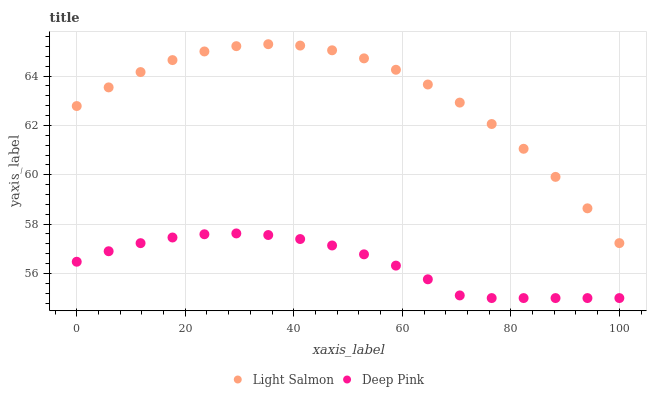Does Deep Pink have the minimum area under the curve?
Answer yes or no. Yes. Does Light Salmon have the maximum area under the curve?
Answer yes or no. Yes. Does Deep Pink have the maximum area under the curve?
Answer yes or no. No. Is Deep Pink the smoothest?
Answer yes or no. Yes. Is Light Salmon the roughest?
Answer yes or no. Yes. Is Deep Pink the roughest?
Answer yes or no. No. Does Deep Pink have the lowest value?
Answer yes or no. Yes. Does Light Salmon have the highest value?
Answer yes or no. Yes. Does Deep Pink have the highest value?
Answer yes or no. No. Is Deep Pink less than Light Salmon?
Answer yes or no. Yes. Is Light Salmon greater than Deep Pink?
Answer yes or no. Yes. Does Deep Pink intersect Light Salmon?
Answer yes or no. No. 